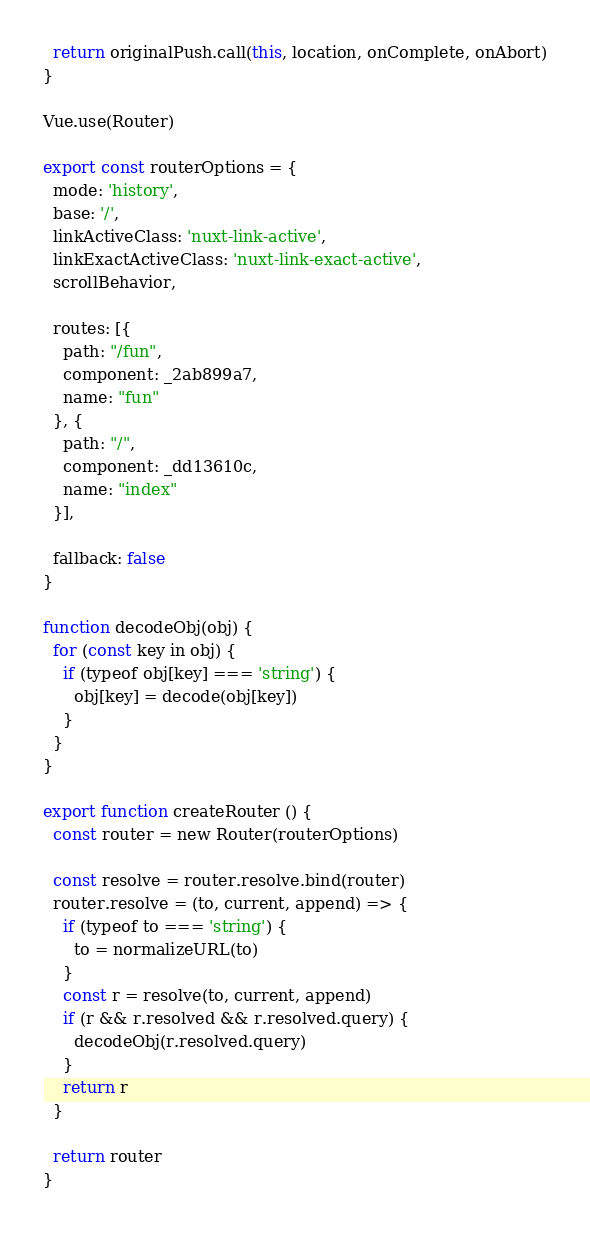Convert code to text. <code><loc_0><loc_0><loc_500><loc_500><_JavaScript_>  return originalPush.call(this, location, onComplete, onAbort)
}

Vue.use(Router)

export const routerOptions = {
  mode: 'history',
  base: '/',
  linkActiveClass: 'nuxt-link-active',
  linkExactActiveClass: 'nuxt-link-exact-active',
  scrollBehavior,

  routes: [{
    path: "/fun",
    component: _2ab899a7,
    name: "fun"
  }, {
    path: "/",
    component: _dd13610c,
    name: "index"
  }],

  fallback: false
}

function decodeObj(obj) {
  for (const key in obj) {
    if (typeof obj[key] === 'string') {
      obj[key] = decode(obj[key])
    }
  }
}

export function createRouter () {
  const router = new Router(routerOptions)

  const resolve = router.resolve.bind(router)
  router.resolve = (to, current, append) => {
    if (typeof to === 'string') {
      to = normalizeURL(to)
    }
    const r = resolve(to, current, append)
    if (r && r.resolved && r.resolved.query) {
      decodeObj(r.resolved.query)
    }
    return r
  }

  return router
}
</code> 